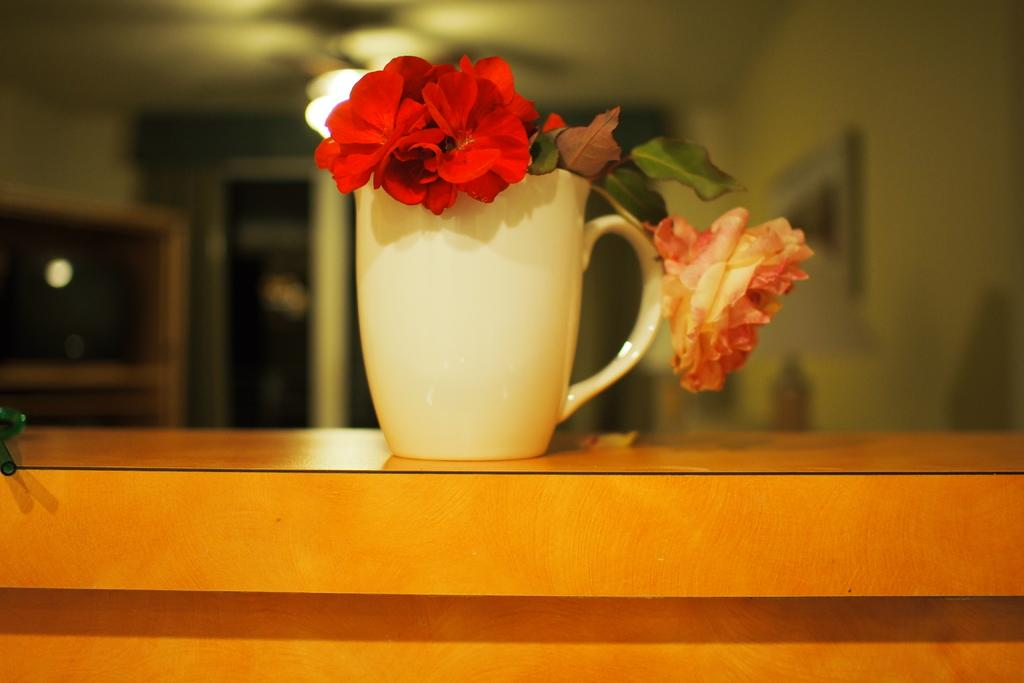What is present in the image that can hold a liquid? There is a cup in the image that can hold a liquid. What type of natural decoration can be seen in the image? There are flowers in the image. What is the source of illumination in the image? There is light in the image. Can you see mom and the deer sitting next to the orange tree in the image? There is no mention of a mom, deer, or orange tree in the provided facts, so we cannot confirm their presence in the image. 